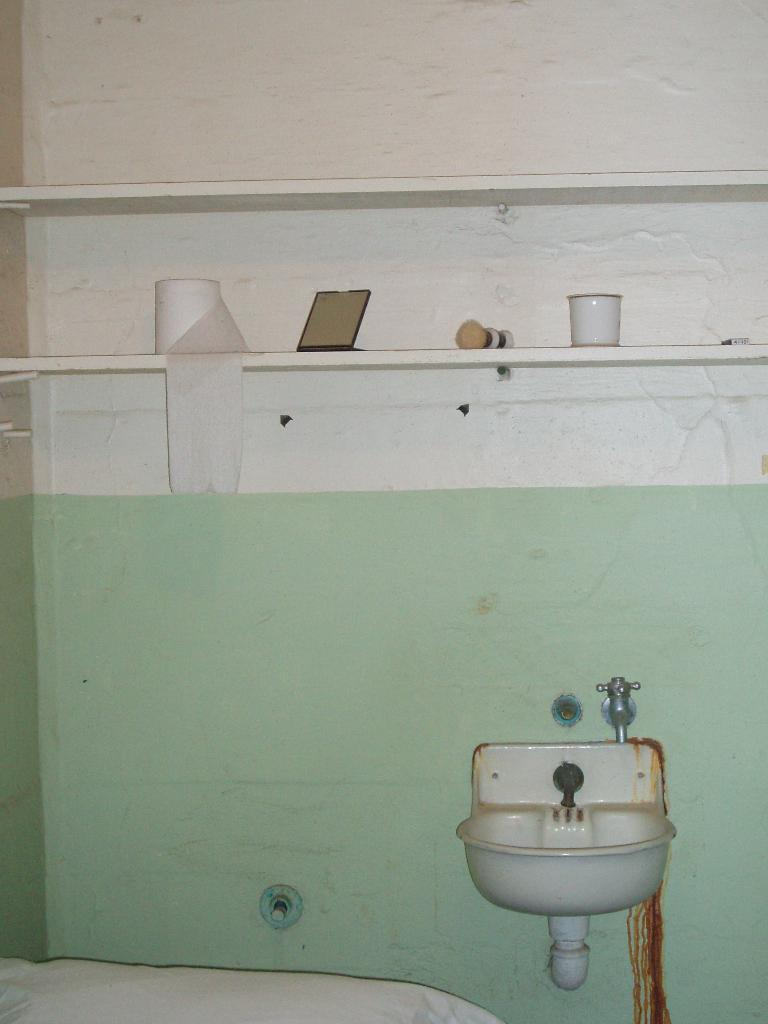What type of fixture is present in the image? There is a white-colored sink in the image. What can be used to control the flow of water in the image? There is a water tap in the image. What is located on the rack in the image? There is a tissue roll, a mirror, a brush, and a white-colored mug on the rack. What type of steel object can be seen in the image? There is no steel object present in the image. Can you describe the language spoken by the crow in the image? There is no crow present in the image, so it is not possible to describe the language spoken by it. 